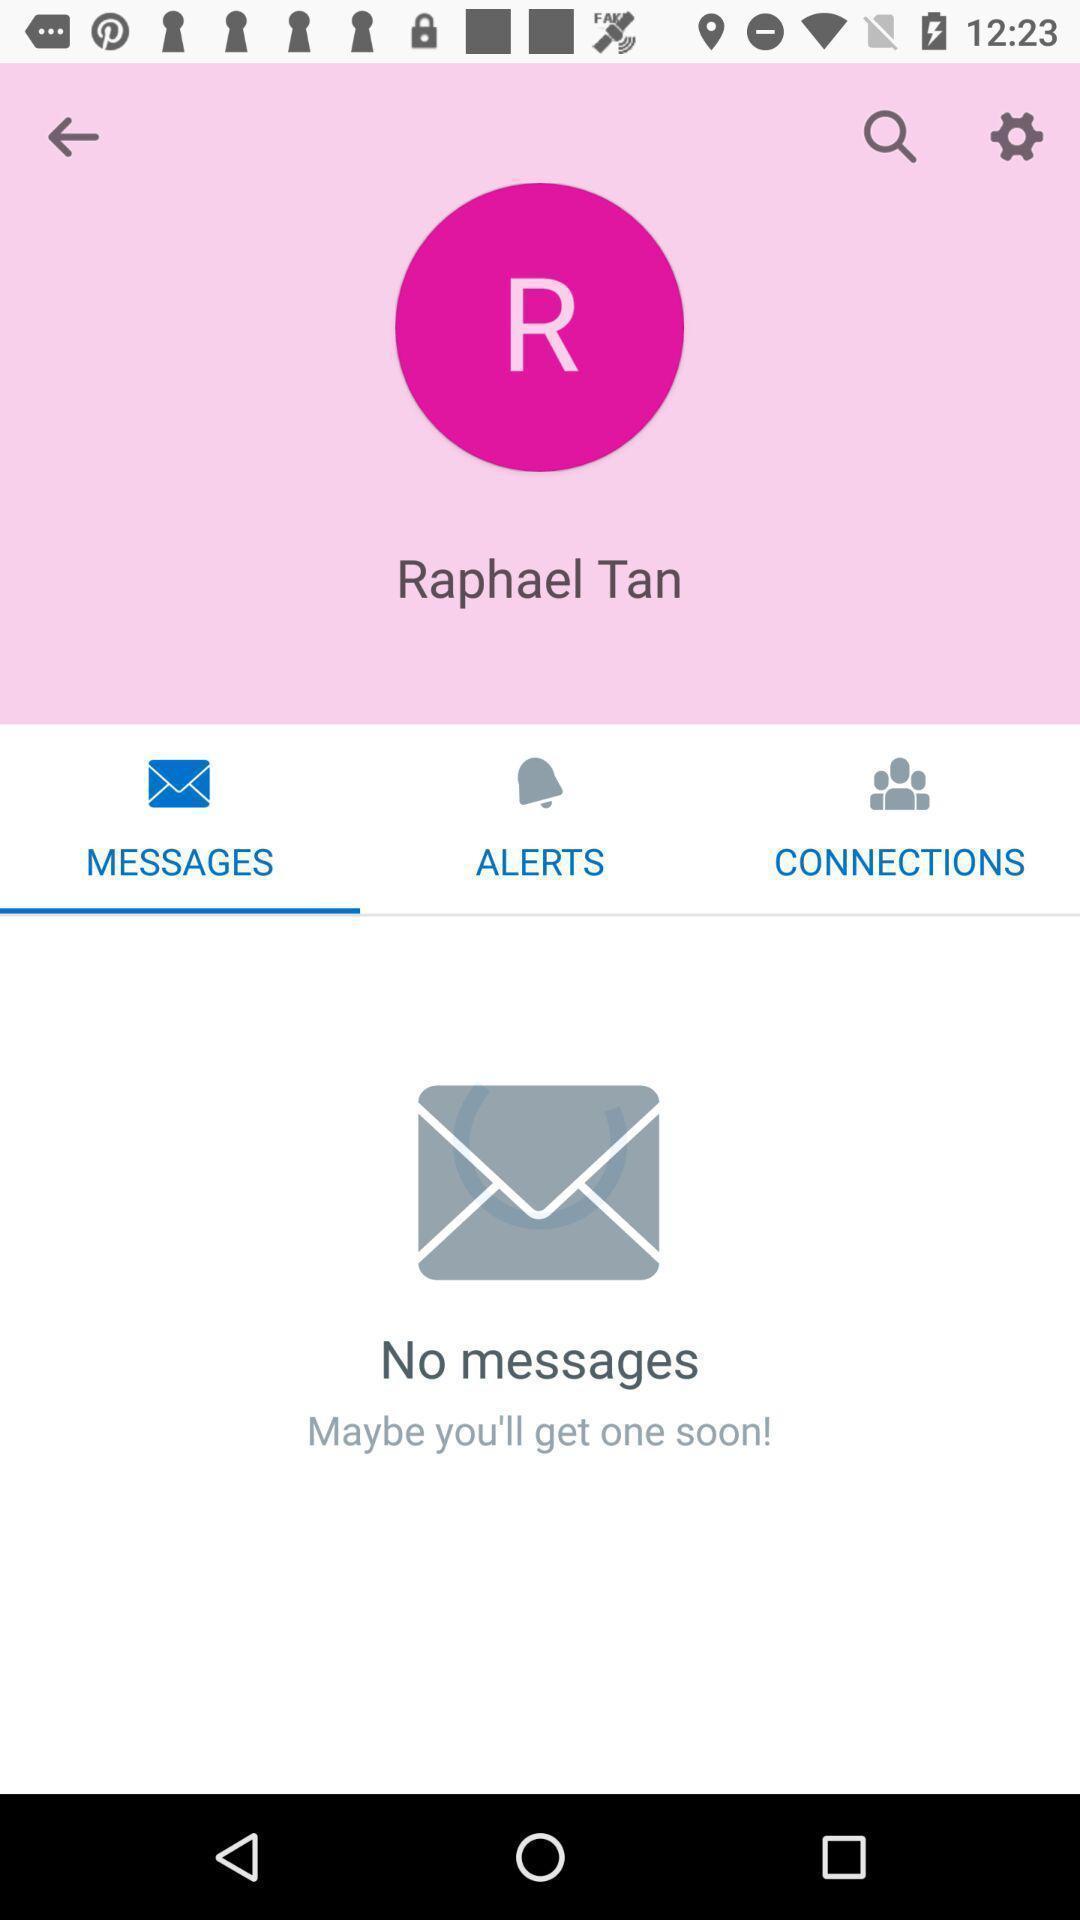Provide a textual representation of this image. Screen page displaying profile with many options in social application. 